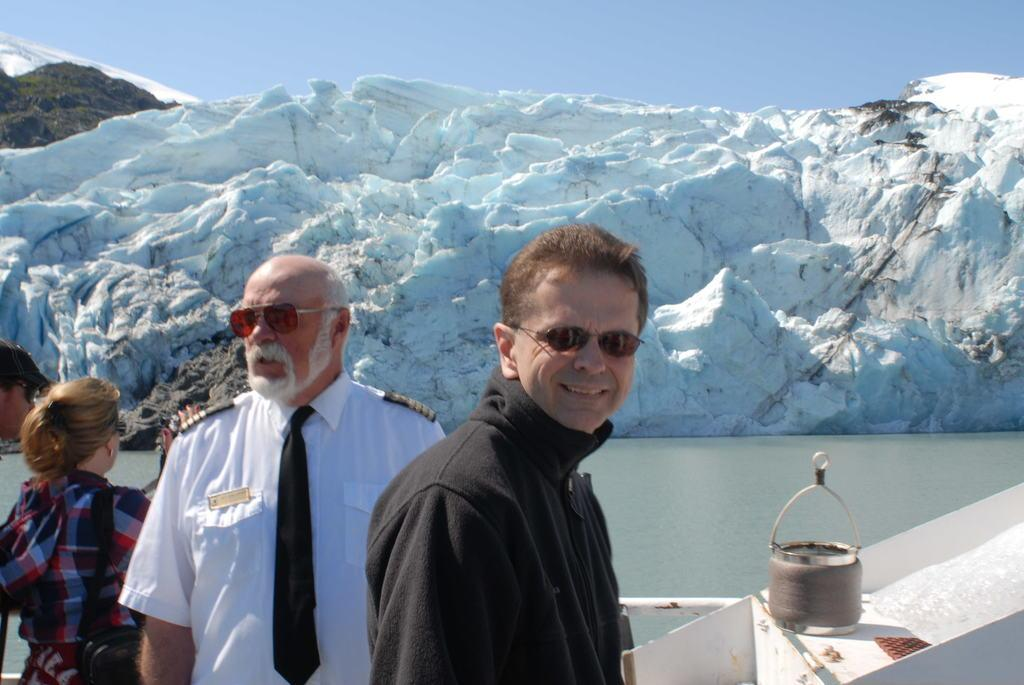What is located in the foreground of the image? There are people in the foreground of the image. What can be seen in the background of the image? There is an ice mountain in the background of the image. What is in the center of the image? There is water in the center of the image. What is the name of the flag flying over the ice mountain in the image? There is no flag present in the image, so it is not possible to determine the name of a flag. 